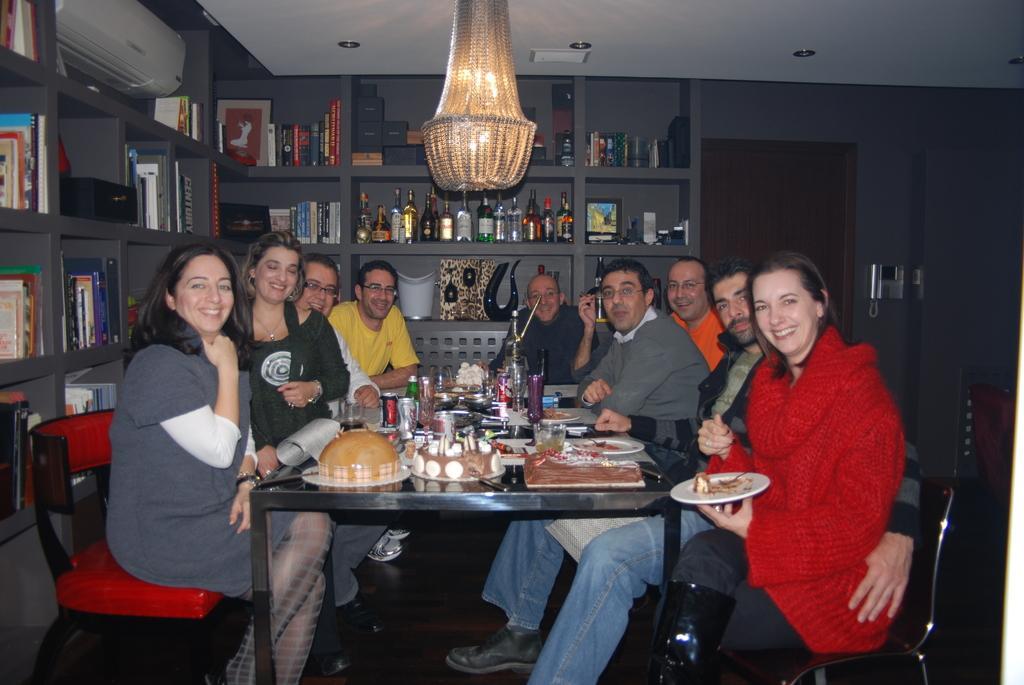Describe this image in one or two sentences. In this picture we can see a group of person sitting on the chair near to the table. On the table we can see cake, plates, spoon, fork, coke cans, bowl, jar, water bottle, glass and other objects. O on the back we can see wine bottles and other objects on the rack. On the top left corner there is a ac. Here we can see many books on the shelf. On the top there is a chandelier. On the right we can see a door near the telephone. 